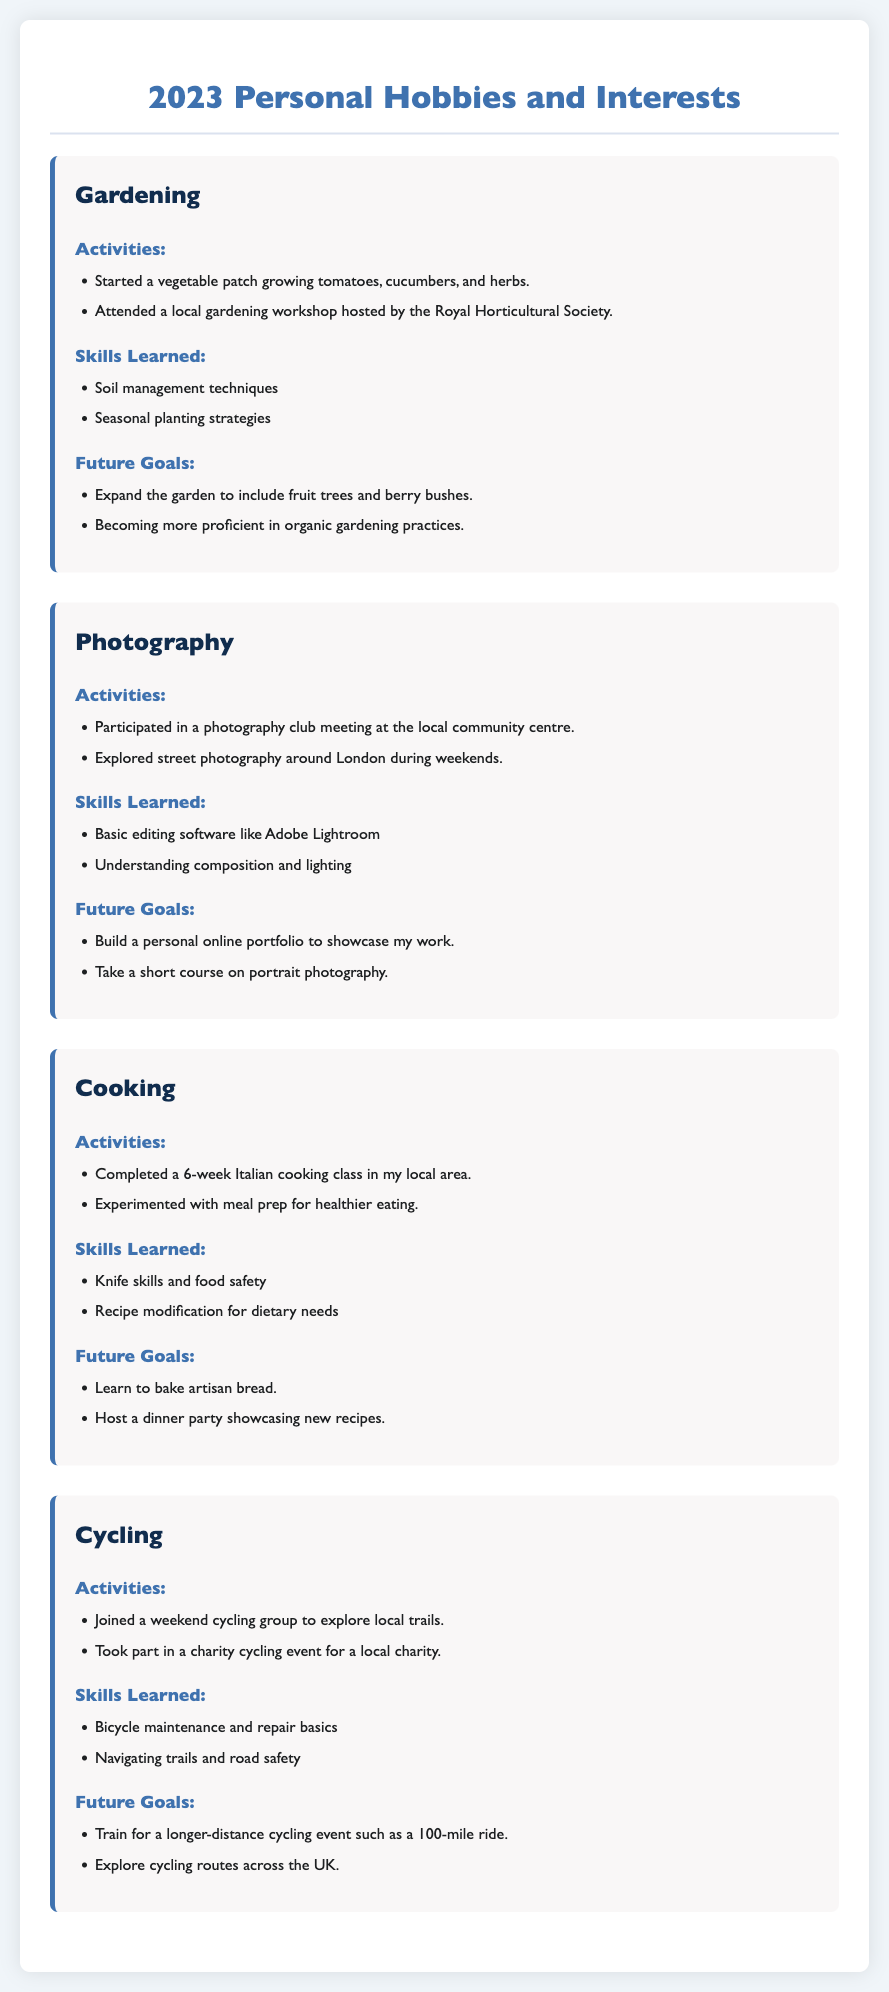What is one type of vegetable grown in the gardening hobby? The document lists tomatoes, cucumbers, and herbs as types of vegetables grown.
Answer: tomatoes What photography skill was learned? Basic editing software like Adobe Lightroom is mentioned as a skill learned in photography.
Answer: Adobe Lightroom How long was the cooking class completed? The cooking class mentioned in the document lasted for 6 weeks.
Answer: 6 weeks What future goal is mentioned for cycling? The document states that a future goal for cycling is to train for a longer-distance cycling event such as a 100-mile ride.
Answer: 100-mile ride What organization hosted the gardening workshop? The Royal Horticultural Society is noted as the host of the gardening workshop.
Answer: Royal Horticultural Society Which hobby involves attending a local club meeting? The document describes attending a club meeting for photography as a hobby activity.
Answer: Photography What type of gardening practices does the individual aim to improve? The document mentions becoming more proficient in organic gardening practices as a future goal.
Answer: organic gardening practices What is a cooking goal related to baking? The future goal for cooking includes learning to bake artisan bread.
Answer: artisan bread 